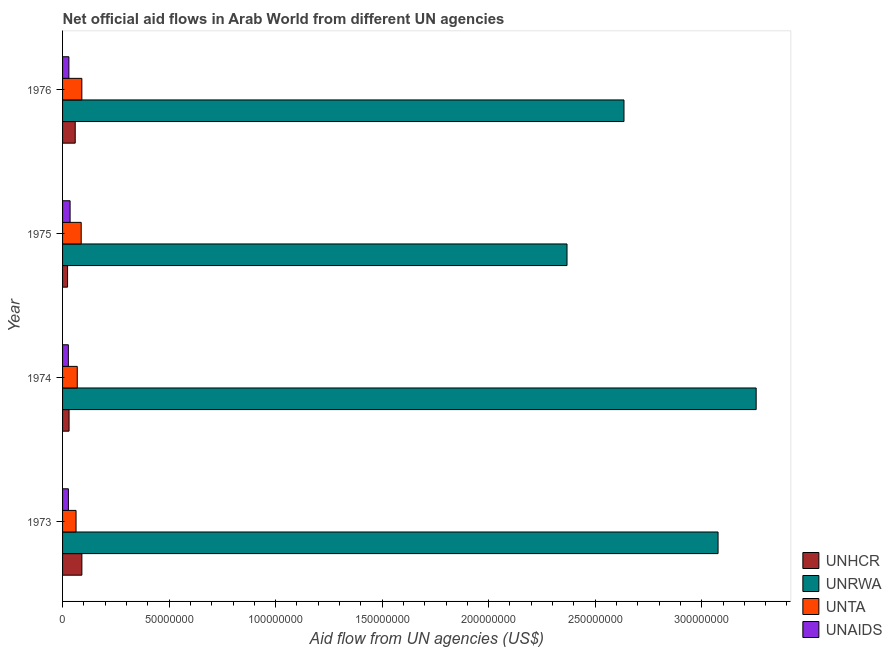How many groups of bars are there?
Your answer should be compact. 4. What is the label of the 3rd group of bars from the top?
Offer a terse response. 1974. In how many cases, is the number of bars for a given year not equal to the number of legend labels?
Make the answer very short. 0. What is the amount of aid given by unaids in 1975?
Your answer should be very brief. 3.53e+06. Across all years, what is the maximum amount of aid given by unhcr?
Give a very brief answer. 9.06e+06. Across all years, what is the minimum amount of aid given by unrwa?
Provide a succinct answer. 2.37e+08. In which year was the amount of aid given by unta maximum?
Offer a terse response. 1976. In which year was the amount of aid given by unrwa minimum?
Keep it short and to the point. 1975. What is the total amount of aid given by unhcr in the graph?
Provide a short and direct response. 2.04e+07. What is the difference between the amount of aid given by unta in 1975 and that in 1976?
Offer a very short reply. -3.00e+05. What is the difference between the amount of aid given by unrwa in 1974 and the amount of aid given by unhcr in 1976?
Your response must be concise. 3.20e+08. What is the average amount of aid given by unrwa per year?
Offer a terse response. 2.83e+08. In the year 1975, what is the difference between the amount of aid given by unhcr and amount of aid given by unta?
Offer a very short reply. -6.40e+06. What is the ratio of the amount of aid given by unaids in 1974 to that in 1975?
Give a very brief answer. 0.77. What is the difference between the highest and the second highest amount of aid given by unaids?
Ensure brevity in your answer.  5.60e+05. What is the difference between the highest and the lowest amount of aid given by unaids?
Offer a very short reply. 8.10e+05. Is the sum of the amount of aid given by unta in 1974 and 1975 greater than the maximum amount of aid given by unhcr across all years?
Provide a succinct answer. Yes. Is it the case that in every year, the sum of the amount of aid given by unaids and amount of aid given by unhcr is greater than the sum of amount of aid given by unta and amount of aid given by unrwa?
Make the answer very short. No. What does the 4th bar from the top in 1975 represents?
Your response must be concise. UNHCR. What does the 4th bar from the bottom in 1973 represents?
Your response must be concise. UNAIDS. Is it the case that in every year, the sum of the amount of aid given by unhcr and amount of aid given by unrwa is greater than the amount of aid given by unta?
Your answer should be very brief. Yes. How many bars are there?
Give a very brief answer. 16. How many years are there in the graph?
Keep it short and to the point. 4. What is the difference between two consecutive major ticks on the X-axis?
Ensure brevity in your answer.  5.00e+07. What is the title of the graph?
Your response must be concise. Net official aid flows in Arab World from different UN agencies. Does "Energy" appear as one of the legend labels in the graph?
Your response must be concise. No. What is the label or title of the X-axis?
Give a very brief answer. Aid flow from UN agencies (US$). What is the label or title of the Y-axis?
Provide a short and direct response. Year. What is the Aid flow from UN agencies (US$) in UNHCR in 1973?
Your response must be concise. 9.06e+06. What is the Aid flow from UN agencies (US$) of UNRWA in 1973?
Give a very brief answer. 3.08e+08. What is the Aid flow from UN agencies (US$) in UNTA in 1973?
Make the answer very short. 6.33e+06. What is the Aid flow from UN agencies (US$) in UNAIDS in 1973?
Your response must be concise. 2.74e+06. What is the Aid flow from UN agencies (US$) in UNHCR in 1974?
Provide a succinct answer. 3.05e+06. What is the Aid flow from UN agencies (US$) in UNRWA in 1974?
Provide a succinct answer. 3.26e+08. What is the Aid flow from UN agencies (US$) of UNTA in 1974?
Your response must be concise. 6.90e+06. What is the Aid flow from UN agencies (US$) of UNAIDS in 1974?
Offer a terse response. 2.72e+06. What is the Aid flow from UN agencies (US$) of UNHCR in 1975?
Provide a succinct answer. 2.35e+06. What is the Aid flow from UN agencies (US$) in UNRWA in 1975?
Keep it short and to the point. 2.37e+08. What is the Aid flow from UN agencies (US$) of UNTA in 1975?
Ensure brevity in your answer.  8.75e+06. What is the Aid flow from UN agencies (US$) of UNAIDS in 1975?
Provide a succinct answer. 3.53e+06. What is the Aid flow from UN agencies (US$) of UNHCR in 1976?
Make the answer very short. 5.94e+06. What is the Aid flow from UN agencies (US$) in UNRWA in 1976?
Provide a succinct answer. 2.64e+08. What is the Aid flow from UN agencies (US$) of UNTA in 1976?
Provide a succinct answer. 9.05e+06. What is the Aid flow from UN agencies (US$) of UNAIDS in 1976?
Keep it short and to the point. 2.97e+06. Across all years, what is the maximum Aid flow from UN agencies (US$) of UNHCR?
Offer a very short reply. 9.06e+06. Across all years, what is the maximum Aid flow from UN agencies (US$) in UNRWA?
Your response must be concise. 3.26e+08. Across all years, what is the maximum Aid flow from UN agencies (US$) of UNTA?
Provide a short and direct response. 9.05e+06. Across all years, what is the maximum Aid flow from UN agencies (US$) in UNAIDS?
Your answer should be very brief. 3.53e+06. Across all years, what is the minimum Aid flow from UN agencies (US$) of UNHCR?
Provide a succinct answer. 2.35e+06. Across all years, what is the minimum Aid flow from UN agencies (US$) in UNRWA?
Provide a succinct answer. 2.37e+08. Across all years, what is the minimum Aid flow from UN agencies (US$) in UNTA?
Offer a terse response. 6.33e+06. Across all years, what is the minimum Aid flow from UN agencies (US$) of UNAIDS?
Provide a short and direct response. 2.72e+06. What is the total Aid flow from UN agencies (US$) in UNHCR in the graph?
Keep it short and to the point. 2.04e+07. What is the total Aid flow from UN agencies (US$) in UNRWA in the graph?
Your response must be concise. 1.13e+09. What is the total Aid flow from UN agencies (US$) of UNTA in the graph?
Offer a terse response. 3.10e+07. What is the total Aid flow from UN agencies (US$) in UNAIDS in the graph?
Ensure brevity in your answer.  1.20e+07. What is the difference between the Aid flow from UN agencies (US$) of UNHCR in 1973 and that in 1974?
Give a very brief answer. 6.01e+06. What is the difference between the Aid flow from UN agencies (US$) of UNRWA in 1973 and that in 1974?
Ensure brevity in your answer.  -1.79e+07. What is the difference between the Aid flow from UN agencies (US$) of UNTA in 1973 and that in 1974?
Offer a terse response. -5.70e+05. What is the difference between the Aid flow from UN agencies (US$) in UNHCR in 1973 and that in 1975?
Provide a short and direct response. 6.71e+06. What is the difference between the Aid flow from UN agencies (US$) in UNRWA in 1973 and that in 1975?
Ensure brevity in your answer.  7.09e+07. What is the difference between the Aid flow from UN agencies (US$) in UNTA in 1973 and that in 1975?
Keep it short and to the point. -2.42e+06. What is the difference between the Aid flow from UN agencies (US$) of UNAIDS in 1973 and that in 1975?
Your response must be concise. -7.90e+05. What is the difference between the Aid flow from UN agencies (US$) of UNHCR in 1973 and that in 1976?
Provide a succinct answer. 3.12e+06. What is the difference between the Aid flow from UN agencies (US$) in UNRWA in 1973 and that in 1976?
Your response must be concise. 4.42e+07. What is the difference between the Aid flow from UN agencies (US$) in UNTA in 1973 and that in 1976?
Give a very brief answer. -2.72e+06. What is the difference between the Aid flow from UN agencies (US$) of UNAIDS in 1973 and that in 1976?
Your response must be concise. -2.30e+05. What is the difference between the Aid flow from UN agencies (US$) of UNHCR in 1974 and that in 1975?
Offer a very short reply. 7.00e+05. What is the difference between the Aid flow from UN agencies (US$) of UNRWA in 1974 and that in 1975?
Ensure brevity in your answer.  8.88e+07. What is the difference between the Aid flow from UN agencies (US$) of UNTA in 1974 and that in 1975?
Keep it short and to the point. -1.85e+06. What is the difference between the Aid flow from UN agencies (US$) in UNAIDS in 1974 and that in 1975?
Your answer should be very brief. -8.10e+05. What is the difference between the Aid flow from UN agencies (US$) in UNHCR in 1974 and that in 1976?
Keep it short and to the point. -2.89e+06. What is the difference between the Aid flow from UN agencies (US$) of UNRWA in 1974 and that in 1976?
Your answer should be compact. 6.20e+07. What is the difference between the Aid flow from UN agencies (US$) in UNTA in 1974 and that in 1976?
Ensure brevity in your answer.  -2.15e+06. What is the difference between the Aid flow from UN agencies (US$) of UNAIDS in 1974 and that in 1976?
Provide a short and direct response. -2.50e+05. What is the difference between the Aid flow from UN agencies (US$) of UNHCR in 1975 and that in 1976?
Provide a succinct answer. -3.59e+06. What is the difference between the Aid flow from UN agencies (US$) of UNRWA in 1975 and that in 1976?
Your response must be concise. -2.67e+07. What is the difference between the Aid flow from UN agencies (US$) of UNAIDS in 1975 and that in 1976?
Your answer should be very brief. 5.60e+05. What is the difference between the Aid flow from UN agencies (US$) in UNHCR in 1973 and the Aid flow from UN agencies (US$) in UNRWA in 1974?
Give a very brief answer. -3.17e+08. What is the difference between the Aid flow from UN agencies (US$) in UNHCR in 1973 and the Aid flow from UN agencies (US$) in UNTA in 1974?
Ensure brevity in your answer.  2.16e+06. What is the difference between the Aid flow from UN agencies (US$) in UNHCR in 1973 and the Aid flow from UN agencies (US$) in UNAIDS in 1974?
Your response must be concise. 6.34e+06. What is the difference between the Aid flow from UN agencies (US$) of UNRWA in 1973 and the Aid flow from UN agencies (US$) of UNTA in 1974?
Ensure brevity in your answer.  3.01e+08. What is the difference between the Aid flow from UN agencies (US$) of UNRWA in 1973 and the Aid flow from UN agencies (US$) of UNAIDS in 1974?
Offer a terse response. 3.05e+08. What is the difference between the Aid flow from UN agencies (US$) of UNTA in 1973 and the Aid flow from UN agencies (US$) of UNAIDS in 1974?
Make the answer very short. 3.61e+06. What is the difference between the Aid flow from UN agencies (US$) of UNHCR in 1973 and the Aid flow from UN agencies (US$) of UNRWA in 1975?
Provide a succinct answer. -2.28e+08. What is the difference between the Aid flow from UN agencies (US$) in UNHCR in 1973 and the Aid flow from UN agencies (US$) in UNAIDS in 1975?
Keep it short and to the point. 5.53e+06. What is the difference between the Aid flow from UN agencies (US$) in UNRWA in 1973 and the Aid flow from UN agencies (US$) in UNTA in 1975?
Offer a very short reply. 2.99e+08. What is the difference between the Aid flow from UN agencies (US$) in UNRWA in 1973 and the Aid flow from UN agencies (US$) in UNAIDS in 1975?
Provide a short and direct response. 3.04e+08. What is the difference between the Aid flow from UN agencies (US$) in UNTA in 1973 and the Aid flow from UN agencies (US$) in UNAIDS in 1975?
Offer a very short reply. 2.80e+06. What is the difference between the Aid flow from UN agencies (US$) in UNHCR in 1973 and the Aid flow from UN agencies (US$) in UNRWA in 1976?
Provide a succinct answer. -2.54e+08. What is the difference between the Aid flow from UN agencies (US$) in UNHCR in 1973 and the Aid flow from UN agencies (US$) in UNTA in 1976?
Your answer should be very brief. 10000. What is the difference between the Aid flow from UN agencies (US$) of UNHCR in 1973 and the Aid flow from UN agencies (US$) of UNAIDS in 1976?
Offer a terse response. 6.09e+06. What is the difference between the Aid flow from UN agencies (US$) in UNRWA in 1973 and the Aid flow from UN agencies (US$) in UNTA in 1976?
Give a very brief answer. 2.99e+08. What is the difference between the Aid flow from UN agencies (US$) in UNRWA in 1973 and the Aid flow from UN agencies (US$) in UNAIDS in 1976?
Offer a very short reply. 3.05e+08. What is the difference between the Aid flow from UN agencies (US$) in UNTA in 1973 and the Aid flow from UN agencies (US$) in UNAIDS in 1976?
Give a very brief answer. 3.36e+06. What is the difference between the Aid flow from UN agencies (US$) of UNHCR in 1974 and the Aid flow from UN agencies (US$) of UNRWA in 1975?
Keep it short and to the point. -2.34e+08. What is the difference between the Aid flow from UN agencies (US$) in UNHCR in 1974 and the Aid flow from UN agencies (US$) in UNTA in 1975?
Provide a short and direct response. -5.70e+06. What is the difference between the Aid flow from UN agencies (US$) in UNHCR in 1974 and the Aid flow from UN agencies (US$) in UNAIDS in 1975?
Provide a short and direct response. -4.80e+05. What is the difference between the Aid flow from UN agencies (US$) of UNRWA in 1974 and the Aid flow from UN agencies (US$) of UNTA in 1975?
Ensure brevity in your answer.  3.17e+08. What is the difference between the Aid flow from UN agencies (US$) of UNRWA in 1974 and the Aid flow from UN agencies (US$) of UNAIDS in 1975?
Give a very brief answer. 3.22e+08. What is the difference between the Aid flow from UN agencies (US$) in UNTA in 1974 and the Aid flow from UN agencies (US$) in UNAIDS in 1975?
Provide a succinct answer. 3.37e+06. What is the difference between the Aid flow from UN agencies (US$) of UNHCR in 1974 and the Aid flow from UN agencies (US$) of UNRWA in 1976?
Your response must be concise. -2.60e+08. What is the difference between the Aid flow from UN agencies (US$) of UNHCR in 1974 and the Aid flow from UN agencies (US$) of UNTA in 1976?
Provide a short and direct response. -6.00e+06. What is the difference between the Aid flow from UN agencies (US$) in UNRWA in 1974 and the Aid flow from UN agencies (US$) in UNTA in 1976?
Provide a short and direct response. 3.17e+08. What is the difference between the Aid flow from UN agencies (US$) in UNRWA in 1974 and the Aid flow from UN agencies (US$) in UNAIDS in 1976?
Offer a very short reply. 3.23e+08. What is the difference between the Aid flow from UN agencies (US$) of UNTA in 1974 and the Aid flow from UN agencies (US$) of UNAIDS in 1976?
Provide a short and direct response. 3.93e+06. What is the difference between the Aid flow from UN agencies (US$) of UNHCR in 1975 and the Aid flow from UN agencies (US$) of UNRWA in 1976?
Keep it short and to the point. -2.61e+08. What is the difference between the Aid flow from UN agencies (US$) of UNHCR in 1975 and the Aid flow from UN agencies (US$) of UNTA in 1976?
Make the answer very short. -6.70e+06. What is the difference between the Aid flow from UN agencies (US$) of UNHCR in 1975 and the Aid flow from UN agencies (US$) of UNAIDS in 1976?
Give a very brief answer. -6.20e+05. What is the difference between the Aid flow from UN agencies (US$) in UNRWA in 1975 and the Aid flow from UN agencies (US$) in UNTA in 1976?
Make the answer very short. 2.28e+08. What is the difference between the Aid flow from UN agencies (US$) in UNRWA in 1975 and the Aid flow from UN agencies (US$) in UNAIDS in 1976?
Your response must be concise. 2.34e+08. What is the difference between the Aid flow from UN agencies (US$) in UNTA in 1975 and the Aid flow from UN agencies (US$) in UNAIDS in 1976?
Provide a succinct answer. 5.78e+06. What is the average Aid flow from UN agencies (US$) in UNHCR per year?
Ensure brevity in your answer.  5.10e+06. What is the average Aid flow from UN agencies (US$) of UNRWA per year?
Offer a very short reply. 2.83e+08. What is the average Aid flow from UN agencies (US$) of UNTA per year?
Offer a very short reply. 7.76e+06. What is the average Aid flow from UN agencies (US$) of UNAIDS per year?
Provide a succinct answer. 2.99e+06. In the year 1973, what is the difference between the Aid flow from UN agencies (US$) of UNHCR and Aid flow from UN agencies (US$) of UNRWA?
Offer a terse response. -2.99e+08. In the year 1973, what is the difference between the Aid flow from UN agencies (US$) in UNHCR and Aid flow from UN agencies (US$) in UNTA?
Keep it short and to the point. 2.73e+06. In the year 1973, what is the difference between the Aid flow from UN agencies (US$) in UNHCR and Aid flow from UN agencies (US$) in UNAIDS?
Provide a succinct answer. 6.32e+06. In the year 1973, what is the difference between the Aid flow from UN agencies (US$) of UNRWA and Aid flow from UN agencies (US$) of UNTA?
Your answer should be very brief. 3.01e+08. In the year 1973, what is the difference between the Aid flow from UN agencies (US$) of UNRWA and Aid flow from UN agencies (US$) of UNAIDS?
Keep it short and to the point. 3.05e+08. In the year 1973, what is the difference between the Aid flow from UN agencies (US$) in UNTA and Aid flow from UN agencies (US$) in UNAIDS?
Ensure brevity in your answer.  3.59e+06. In the year 1974, what is the difference between the Aid flow from UN agencies (US$) of UNHCR and Aid flow from UN agencies (US$) of UNRWA?
Offer a very short reply. -3.23e+08. In the year 1974, what is the difference between the Aid flow from UN agencies (US$) in UNHCR and Aid flow from UN agencies (US$) in UNTA?
Your response must be concise. -3.85e+06. In the year 1974, what is the difference between the Aid flow from UN agencies (US$) of UNHCR and Aid flow from UN agencies (US$) of UNAIDS?
Your response must be concise. 3.30e+05. In the year 1974, what is the difference between the Aid flow from UN agencies (US$) in UNRWA and Aid flow from UN agencies (US$) in UNTA?
Keep it short and to the point. 3.19e+08. In the year 1974, what is the difference between the Aid flow from UN agencies (US$) of UNRWA and Aid flow from UN agencies (US$) of UNAIDS?
Your response must be concise. 3.23e+08. In the year 1974, what is the difference between the Aid flow from UN agencies (US$) of UNTA and Aid flow from UN agencies (US$) of UNAIDS?
Offer a terse response. 4.18e+06. In the year 1975, what is the difference between the Aid flow from UN agencies (US$) of UNHCR and Aid flow from UN agencies (US$) of UNRWA?
Your response must be concise. -2.34e+08. In the year 1975, what is the difference between the Aid flow from UN agencies (US$) of UNHCR and Aid flow from UN agencies (US$) of UNTA?
Offer a very short reply. -6.40e+06. In the year 1975, what is the difference between the Aid flow from UN agencies (US$) in UNHCR and Aid flow from UN agencies (US$) in UNAIDS?
Provide a short and direct response. -1.18e+06. In the year 1975, what is the difference between the Aid flow from UN agencies (US$) of UNRWA and Aid flow from UN agencies (US$) of UNTA?
Offer a very short reply. 2.28e+08. In the year 1975, what is the difference between the Aid flow from UN agencies (US$) in UNRWA and Aid flow from UN agencies (US$) in UNAIDS?
Keep it short and to the point. 2.33e+08. In the year 1975, what is the difference between the Aid flow from UN agencies (US$) in UNTA and Aid flow from UN agencies (US$) in UNAIDS?
Ensure brevity in your answer.  5.22e+06. In the year 1976, what is the difference between the Aid flow from UN agencies (US$) in UNHCR and Aid flow from UN agencies (US$) in UNRWA?
Make the answer very short. -2.58e+08. In the year 1976, what is the difference between the Aid flow from UN agencies (US$) of UNHCR and Aid flow from UN agencies (US$) of UNTA?
Offer a very short reply. -3.11e+06. In the year 1976, what is the difference between the Aid flow from UN agencies (US$) in UNHCR and Aid flow from UN agencies (US$) in UNAIDS?
Offer a terse response. 2.97e+06. In the year 1976, what is the difference between the Aid flow from UN agencies (US$) in UNRWA and Aid flow from UN agencies (US$) in UNTA?
Your response must be concise. 2.54e+08. In the year 1976, what is the difference between the Aid flow from UN agencies (US$) in UNRWA and Aid flow from UN agencies (US$) in UNAIDS?
Give a very brief answer. 2.61e+08. In the year 1976, what is the difference between the Aid flow from UN agencies (US$) in UNTA and Aid flow from UN agencies (US$) in UNAIDS?
Make the answer very short. 6.08e+06. What is the ratio of the Aid flow from UN agencies (US$) in UNHCR in 1973 to that in 1974?
Make the answer very short. 2.97. What is the ratio of the Aid flow from UN agencies (US$) in UNRWA in 1973 to that in 1974?
Provide a succinct answer. 0.95. What is the ratio of the Aid flow from UN agencies (US$) in UNTA in 1973 to that in 1974?
Provide a succinct answer. 0.92. What is the ratio of the Aid flow from UN agencies (US$) in UNAIDS in 1973 to that in 1974?
Your response must be concise. 1.01. What is the ratio of the Aid flow from UN agencies (US$) of UNHCR in 1973 to that in 1975?
Your answer should be very brief. 3.86. What is the ratio of the Aid flow from UN agencies (US$) in UNRWA in 1973 to that in 1975?
Your answer should be very brief. 1.3. What is the ratio of the Aid flow from UN agencies (US$) in UNTA in 1973 to that in 1975?
Provide a succinct answer. 0.72. What is the ratio of the Aid flow from UN agencies (US$) of UNAIDS in 1973 to that in 1975?
Offer a terse response. 0.78. What is the ratio of the Aid flow from UN agencies (US$) of UNHCR in 1973 to that in 1976?
Offer a very short reply. 1.53. What is the ratio of the Aid flow from UN agencies (US$) of UNRWA in 1973 to that in 1976?
Your response must be concise. 1.17. What is the ratio of the Aid flow from UN agencies (US$) in UNTA in 1973 to that in 1976?
Your response must be concise. 0.7. What is the ratio of the Aid flow from UN agencies (US$) in UNAIDS in 1973 to that in 1976?
Your answer should be compact. 0.92. What is the ratio of the Aid flow from UN agencies (US$) of UNHCR in 1974 to that in 1975?
Your answer should be very brief. 1.3. What is the ratio of the Aid flow from UN agencies (US$) in UNRWA in 1974 to that in 1975?
Your answer should be compact. 1.38. What is the ratio of the Aid flow from UN agencies (US$) in UNTA in 1974 to that in 1975?
Your answer should be very brief. 0.79. What is the ratio of the Aid flow from UN agencies (US$) in UNAIDS in 1974 to that in 1975?
Offer a terse response. 0.77. What is the ratio of the Aid flow from UN agencies (US$) in UNHCR in 1974 to that in 1976?
Keep it short and to the point. 0.51. What is the ratio of the Aid flow from UN agencies (US$) of UNRWA in 1974 to that in 1976?
Make the answer very short. 1.24. What is the ratio of the Aid flow from UN agencies (US$) in UNTA in 1974 to that in 1976?
Ensure brevity in your answer.  0.76. What is the ratio of the Aid flow from UN agencies (US$) of UNAIDS in 1974 to that in 1976?
Your answer should be very brief. 0.92. What is the ratio of the Aid flow from UN agencies (US$) of UNHCR in 1975 to that in 1976?
Ensure brevity in your answer.  0.4. What is the ratio of the Aid flow from UN agencies (US$) of UNRWA in 1975 to that in 1976?
Your answer should be very brief. 0.9. What is the ratio of the Aid flow from UN agencies (US$) of UNTA in 1975 to that in 1976?
Keep it short and to the point. 0.97. What is the ratio of the Aid flow from UN agencies (US$) in UNAIDS in 1975 to that in 1976?
Provide a succinct answer. 1.19. What is the difference between the highest and the second highest Aid flow from UN agencies (US$) of UNHCR?
Provide a short and direct response. 3.12e+06. What is the difference between the highest and the second highest Aid flow from UN agencies (US$) in UNRWA?
Give a very brief answer. 1.79e+07. What is the difference between the highest and the second highest Aid flow from UN agencies (US$) of UNAIDS?
Provide a short and direct response. 5.60e+05. What is the difference between the highest and the lowest Aid flow from UN agencies (US$) in UNHCR?
Offer a very short reply. 6.71e+06. What is the difference between the highest and the lowest Aid flow from UN agencies (US$) in UNRWA?
Provide a short and direct response. 8.88e+07. What is the difference between the highest and the lowest Aid flow from UN agencies (US$) in UNTA?
Your answer should be very brief. 2.72e+06. What is the difference between the highest and the lowest Aid flow from UN agencies (US$) in UNAIDS?
Make the answer very short. 8.10e+05. 